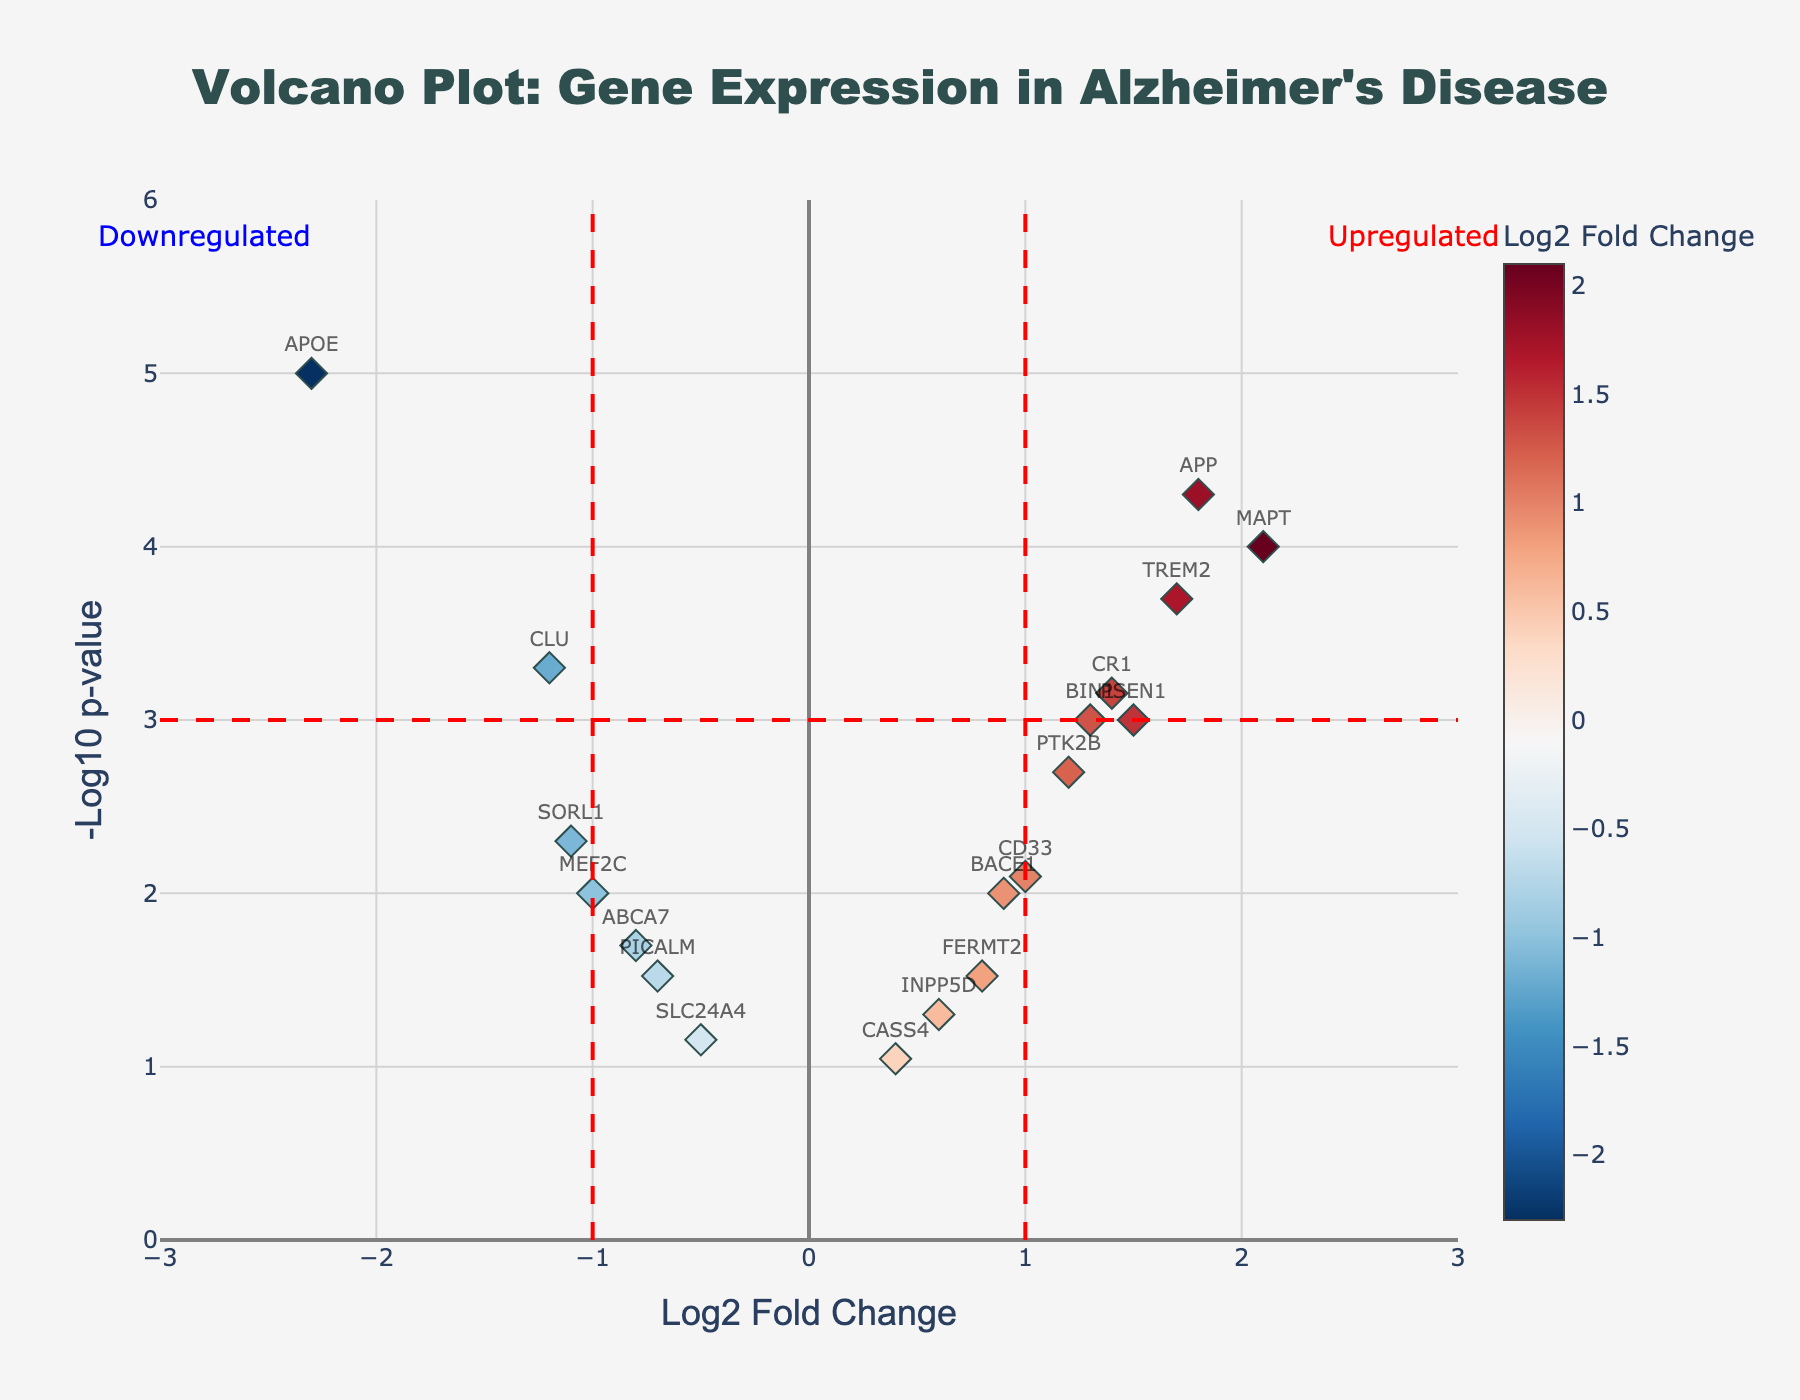How many genes are represented in the volcano plot? Count the number of data points associated with gene names on the plot. Each gene name corresponds to one data point.
Answer: 18 What is the title of the plot? Look at the top of the plot to read the title displayed.
Answer: Volcano Plot: Gene Expression in Alzheimer's Disease Which gene has the highest -log10(p-value)? Identify the gene name with the highest value on the y-axis (-log10(p-value)).
Answer: APOE What does a positive log2 fold change indicate in this plot? A positive log2 fold change indicates upregulation of the gene in Alzheimer's patients compared to healthy controls.
Answer: Upregulation Which gene exhibits the most significant downregulation? Look for the gene with the most negative log2 fold change and highest -log10(p-value).
Answer: APOE How many genes are significantly downregulated? Identify the number of points on the left side of the horizontal significance line (-1 on the x-axis) with a y-value above the horizontal significance line (3 on the y-axis).
Answer: 3 Which genes have a log2 fold change less than 0 but are not considered significant? Identify the genes on the left side of the vertical line (log2 fold change less than -1) but below the -log10(p-value) threshold of 3.
Answer: ABCA7, PICALM, SLC24A4 Which two genes have similar levels of upregulation but different levels of significance? Identify genes that have close log2 fold change values but different -log10(p-value) values.
Answer: TREM2 and CR1 What does the horizontal red dashed line at y=3 indicate? The horizontal red dashed line signifies the -log10(p-value) threshold (i.e., p-value of 0.001) above which genes are considered statistically significant.
Answer: Significance threshold Which gene has a log2 fold change closest to zero but is still considered significant? Find the gene closest to zero on the x-axis but above the significance threshold (y > 3).
Answer: BACE1 